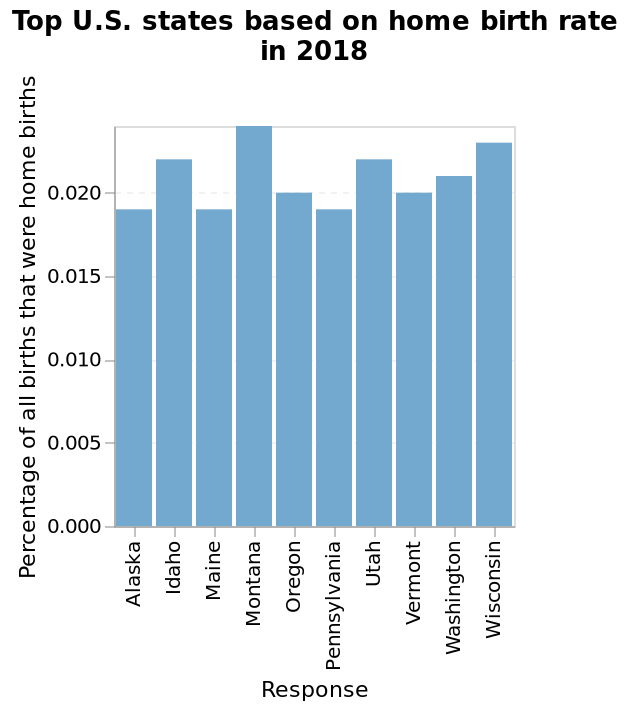<image>
Which state has the highest percentage of home births?  Montana 